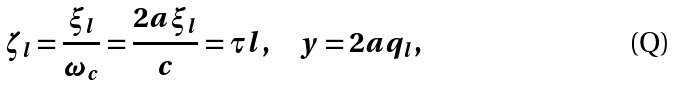Convert formula to latex. <formula><loc_0><loc_0><loc_500><loc_500>\zeta _ { l } = \frac { \xi _ { l } } { \omega _ { c } } = \frac { 2 a \xi _ { l } } { c } = \tau l , \quad y = 2 a q _ { l } ,</formula> 